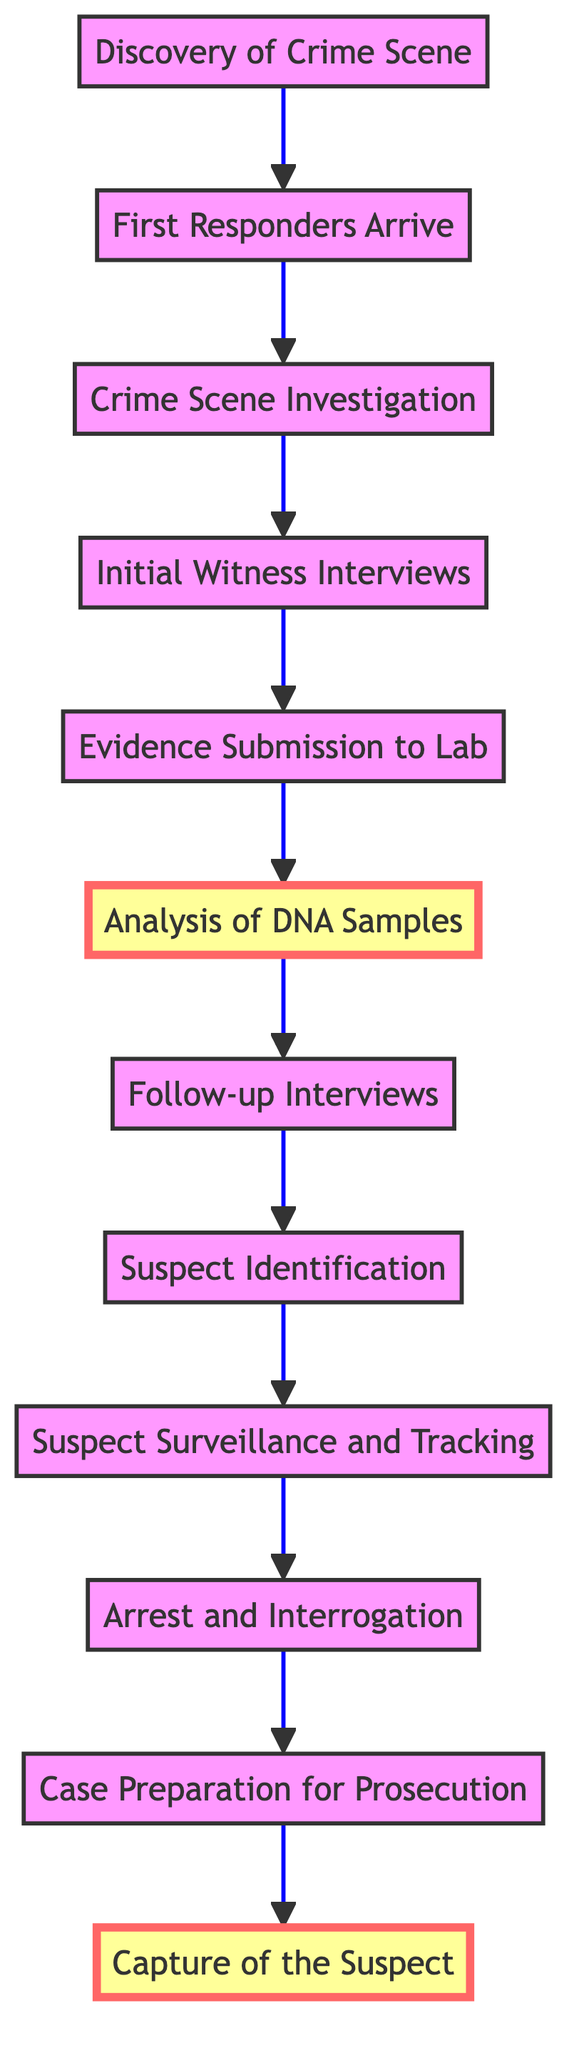What is the first step in the crime investigation timeline? The first step listed in the diagram is "Discovery of Crime Scene." This is directly identified as the initial action in the flowchart.
Answer: Discovery of Crime Scene How many steps are there in the timeline? By counting each distinct labeled step from the diagram, we find there are a total of 12 steps listed in the flowchart.
Answer: 12 Which step follows "Analysis of DNA Samples"? The diagram indicates that "Follow-up Interviews" occurs immediately after "Analysis of DNA Samples" in the flow of the investigation.
Answer: Follow-up Interviews What is the last step leading to the capture of a suspect? The diagram shows that "Case Preparation for Prosecution" is the final step before reaching the "Capture of the Suspect."
Answer: Case Preparation for Prosecution What two steps are highlighted in the diagram? The highlighted steps in the provided diagram are "Analysis of DNA Samples" and "Capture of the Suspect," as indicated by the special formatting applied to these nodes.
Answer: Analysis of DNA Samples, Capture of the Suspect What type of evidence is collected during the "Crime Scene Investigation"? During this step, the CSI team collects physical evidence such as fingerprints, blood samples, and weapons, as specified in the description.
Answer: Physical evidence Which step includes having in-depth conversations with witnesses? The "Follow-up Interviews" step is specifically where detectives conduct in-depth interviews with witnesses to gain more information about the case.
Answer: Follow-up Interviews What action proceeds after "Suspect Identification"? According to the flowchart, after "Suspect Identification," the next step is "Suspect Surveillance and Tracking," where police continue to monitor the suspect.
Answer: Suspect Surveillance and Tracking Which step occurs just before the "Arrest and Interrogation"? The step that immediately precedes "Arrest and Interrogation" is "Suspect Surveillance and Tracking," indicating the process leading to the arrest.
Answer: Suspect Surveillance and Tracking What is primarily analyzed in the "Analysis of DNA Samples"? In this step, forensic scientists focus on analyzing DNA samples to identify potential suspects or victims specifically.
Answer: DNA samples 